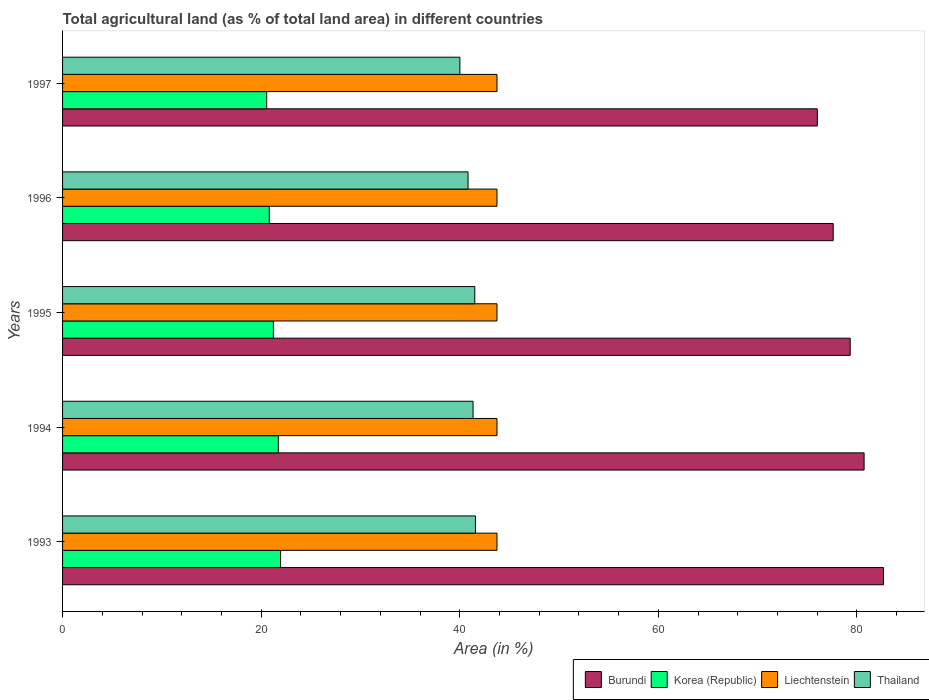What is the label of the 3rd group of bars from the top?
Make the answer very short. 1995. What is the percentage of agricultural land in Burundi in 1995?
Offer a terse response. 79.32. Across all years, what is the maximum percentage of agricultural land in Korea (Republic)?
Make the answer very short. 21.96. Across all years, what is the minimum percentage of agricultural land in Burundi?
Provide a succinct answer. 76.01. In which year was the percentage of agricultural land in Korea (Republic) maximum?
Provide a short and direct response. 1993. In which year was the percentage of agricultural land in Korea (Republic) minimum?
Your answer should be compact. 1997. What is the total percentage of agricultural land in Thailand in the graph?
Provide a succinct answer. 205.29. What is the difference between the percentage of agricultural land in Burundi in 1993 and that in 1997?
Give a very brief answer. 6.66. What is the difference between the percentage of agricultural land in Liechtenstein in 1994 and the percentage of agricultural land in Thailand in 1997?
Ensure brevity in your answer.  3.74. What is the average percentage of agricultural land in Burundi per year?
Ensure brevity in your answer.  79.27. In the year 1994, what is the difference between the percentage of agricultural land in Burundi and percentage of agricultural land in Thailand?
Your response must be concise. 39.38. What is the ratio of the percentage of agricultural land in Thailand in 1993 to that in 1994?
Keep it short and to the point. 1.01. Is the difference between the percentage of agricultural land in Burundi in 1993 and 1995 greater than the difference between the percentage of agricultural land in Thailand in 1993 and 1995?
Keep it short and to the point. Yes. What is the difference between the highest and the lowest percentage of agricultural land in Thailand?
Make the answer very short. 1.57. In how many years, is the percentage of agricultural land in Burundi greater than the average percentage of agricultural land in Burundi taken over all years?
Ensure brevity in your answer.  3. Is the sum of the percentage of agricultural land in Burundi in 1993 and 1996 greater than the maximum percentage of agricultural land in Korea (Republic) across all years?
Offer a very short reply. Yes. What does the 4th bar from the top in 1997 represents?
Your answer should be very brief. Burundi. What does the 1st bar from the bottom in 1997 represents?
Give a very brief answer. Burundi. Is it the case that in every year, the sum of the percentage of agricultural land in Korea (Republic) and percentage of agricultural land in Burundi is greater than the percentage of agricultural land in Thailand?
Offer a terse response. Yes. How many bars are there?
Your answer should be very brief. 20. Are all the bars in the graph horizontal?
Offer a very short reply. Yes. How many years are there in the graph?
Make the answer very short. 5. Are the values on the major ticks of X-axis written in scientific E-notation?
Provide a succinct answer. No. Does the graph contain grids?
Give a very brief answer. No. What is the title of the graph?
Your response must be concise. Total agricultural land (as % of total land area) in different countries. What is the label or title of the X-axis?
Your answer should be compact. Area (in %). What is the Area (in %) of Burundi in 1993?
Keep it short and to the point. 82.67. What is the Area (in %) of Korea (Republic) in 1993?
Make the answer very short. 21.96. What is the Area (in %) of Liechtenstein in 1993?
Offer a terse response. 43.75. What is the Area (in %) of Thailand in 1993?
Your answer should be compact. 41.58. What is the Area (in %) of Burundi in 1994?
Ensure brevity in your answer.  80.72. What is the Area (in %) in Korea (Republic) in 1994?
Your response must be concise. 21.73. What is the Area (in %) of Liechtenstein in 1994?
Give a very brief answer. 43.75. What is the Area (in %) in Thailand in 1994?
Your answer should be very brief. 41.34. What is the Area (in %) of Burundi in 1995?
Offer a terse response. 79.32. What is the Area (in %) of Korea (Republic) in 1995?
Your answer should be compact. 21.23. What is the Area (in %) in Liechtenstein in 1995?
Provide a short and direct response. 43.75. What is the Area (in %) of Thailand in 1995?
Provide a short and direct response. 41.52. What is the Area (in %) of Burundi in 1996?
Give a very brief answer. 77.61. What is the Area (in %) of Korea (Republic) in 1996?
Make the answer very short. 20.82. What is the Area (in %) of Liechtenstein in 1996?
Ensure brevity in your answer.  43.75. What is the Area (in %) in Thailand in 1996?
Offer a terse response. 40.84. What is the Area (in %) of Burundi in 1997?
Provide a succinct answer. 76.01. What is the Area (in %) in Korea (Republic) in 1997?
Make the answer very short. 20.56. What is the Area (in %) in Liechtenstein in 1997?
Ensure brevity in your answer.  43.75. What is the Area (in %) in Thailand in 1997?
Keep it short and to the point. 40.01. Across all years, what is the maximum Area (in %) in Burundi?
Your answer should be very brief. 82.67. Across all years, what is the maximum Area (in %) in Korea (Republic)?
Your answer should be very brief. 21.96. Across all years, what is the maximum Area (in %) of Liechtenstein?
Your answer should be very brief. 43.75. Across all years, what is the maximum Area (in %) in Thailand?
Provide a succinct answer. 41.58. Across all years, what is the minimum Area (in %) of Burundi?
Provide a short and direct response. 76.01. Across all years, what is the minimum Area (in %) of Korea (Republic)?
Your response must be concise. 20.56. Across all years, what is the minimum Area (in %) in Liechtenstein?
Provide a succinct answer. 43.75. Across all years, what is the minimum Area (in %) of Thailand?
Your answer should be compact. 40.01. What is the total Area (in %) of Burundi in the graph?
Provide a short and direct response. 396.34. What is the total Area (in %) of Korea (Republic) in the graph?
Your response must be concise. 106.29. What is the total Area (in %) of Liechtenstein in the graph?
Ensure brevity in your answer.  218.75. What is the total Area (in %) of Thailand in the graph?
Ensure brevity in your answer.  205.29. What is the difference between the Area (in %) of Burundi in 1993 and that in 1994?
Your response must be concise. 1.95. What is the difference between the Area (in %) in Korea (Republic) in 1993 and that in 1994?
Make the answer very short. 0.23. What is the difference between the Area (in %) in Liechtenstein in 1993 and that in 1994?
Provide a succinct answer. 0. What is the difference between the Area (in %) in Thailand in 1993 and that in 1994?
Ensure brevity in your answer.  0.24. What is the difference between the Area (in %) in Burundi in 1993 and that in 1995?
Offer a very short reply. 3.35. What is the difference between the Area (in %) in Korea (Republic) in 1993 and that in 1995?
Provide a succinct answer. 0.73. What is the difference between the Area (in %) of Thailand in 1993 and that in 1995?
Ensure brevity in your answer.  0.07. What is the difference between the Area (in %) in Burundi in 1993 and that in 1996?
Keep it short and to the point. 5.06. What is the difference between the Area (in %) in Korea (Republic) in 1993 and that in 1996?
Provide a succinct answer. 1.14. What is the difference between the Area (in %) of Liechtenstein in 1993 and that in 1996?
Your answer should be very brief. 0. What is the difference between the Area (in %) in Thailand in 1993 and that in 1996?
Keep it short and to the point. 0.75. What is the difference between the Area (in %) of Burundi in 1993 and that in 1997?
Provide a succinct answer. 6.66. What is the difference between the Area (in %) in Korea (Republic) in 1993 and that in 1997?
Your response must be concise. 1.4. What is the difference between the Area (in %) in Liechtenstein in 1993 and that in 1997?
Give a very brief answer. 0. What is the difference between the Area (in %) in Thailand in 1993 and that in 1997?
Provide a succinct answer. 1.57. What is the difference between the Area (in %) of Burundi in 1994 and that in 1995?
Give a very brief answer. 1.4. What is the difference between the Area (in %) of Korea (Republic) in 1994 and that in 1995?
Make the answer very short. 0.5. What is the difference between the Area (in %) of Liechtenstein in 1994 and that in 1995?
Ensure brevity in your answer.  0. What is the difference between the Area (in %) in Thailand in 1994 and that in 1995?
Offer a very short reply. -0.18. What is the difference between the Area (in %) in Burundi in 1994 and that in 1996?
Provide a short and direct response. 3.12. What is the difference between the Area (in %) of Korea (Republic) in 1994 and that in 1996?
Provide a short and direct response. 0.91. What is the difference between the Area (in %) in Thailand in 1994 and that in 1996?
Your answer should be compact. 0.5. What is the difference between the Area (in %) of Burundi in 1994 and that in 1997?
Provide a succinct answer. 4.71. What is the difference between the Area (in %) of Korea (Republic) in 1994 and that in 1997?
Offer a terse response. 1.17. What is the difference between the Area (in %) in Thailand in 1994 and that in 1997?
Offer a terse response. 1.33. What is the difference between the Area (in %) in Burundi in 1995 and that in 1996?
Your answer should be compact. 1.71. What is the difference between the Area (in %) in Korea (Republic) in 1995 and that in 1996?
Make the answer very short. 0.41. What is the difference between the Area (in %) in Liechtenstein in 1995 and that in 1996?
Offer a terse response. 0. What is the difference between the Area (in %) of Thailand in 1995 and that in 1996?
Provide a succinct answer. 0.68. What is the difference between the Area (in %) of Burundi in 1995 and that in 1997?
Make the answer very short. 3.31. What is the difference between the Area (in %) in Korea (Republic) in 1995 and that in 1997?
Offer a terse response. 0.67. What is the difference between the Area (in %) in Thailand in 1995 and that in 1997?
Keep it short and to the point. 1.5. What is the difference between the Area (in %) in Burundi in 1996 and that in 1997?
Provide a succinct answer. 1.6. What is the difference between the Area (in %) of Korea (Republic) in 1996 and that in 1997?
Your answer should be compact. 0.26. What is the difference between the Area (in %) of Liechtenstein in 1996 and that in 1997?
Provide a succinct answer. 0. What is the difference between the Area (in %) in Thailand in 1996 and that in 1997?
Offer a very short reply. 0.82. What is the difference between the Area (in %) in Burundi in 1993 and the Area (in %) in Korea (Republic) in 1994?
Offer a very short reply. 60.94. What is the difference between the Area (in %) of Burundi in 1993 and the Area (in %) of Liechtenstein in 1994?
Your answer should be compact. 38.92. What is the difference between the Area (in %) in Burundi in 1993 and the Area (in %) in Thailand in 1994?
Ensure brevity in your answer.  41.33. What is the difference between the Area (in %) in Korea (Republic) in 1993 and the Area (in %) in Liechtenstein in 1994?
Your answer should be compact. -21.79. What is the difference between the Area (in %) in Korea (Republic) in 1993 and the Area (in %) in Thailand in 1994?
Provide a short and direct response. -19.38. What is the difference between the Area (in %) in Liechtenstein in 1993 and the Area (in %) in Thailand in 1994?
Make the answer very short. 2.41. What is the difference between the Area (in %) of Burundi in 1993 and the Area (in %) of Korea (Republic) in 1995?
Your response must be concise. 61.44. What is the difference between the Area (in %) of Burundi in 1993 and the Area (in %) of Liechtenstein in 1995?
Your answer should be very brief. 38.92. What is the difference between the Area (in %) in Burundi in 1993 and the Area (in %) in Thailand in 1995?
Offer a terse response. 41.16. What is the difference between the Area (in %) in Korea (Republic) in 1993 and the Area (in %) in Liechtenstein in 1995?
Provide a short and direct response. -21.79. What is the difference between the Area (in %) in Korea (Republic) in 1993 and the Area (in %) in Thailand in 1995?
Offer a very short reply. -19.56. What is the difference between the Area (in %) in Liechtenstein in 1993 and the Area (in %) in Thailand in 1995?
Your answer should be very brief. 2.23. What is the difference between the Area (in %) in Burundi in 1993 and the Area (in %) in Korea (Republic) in 1996?
Give a very brief answer. 61.85. What is the difference between the Area (in %) of Burundi in 1993 and the Area (in %) of Liechtenstein in 1996?
Ensure brevity in your answer.  38.92. What is the difference between the Area (in %) in Burundi in 1993 and the Area (in %) in Thailand in 1996?
Provide a short and direct response. 41.83. What is the difference between the Area (in %) in Korea (Republic) in 1993 and the Area (in %) in Liechtenstein in 1996?
Give a very brief answer. -21.79. What is the difference between the Area (in %) in Korea (Republic) in 1993 and the Area (in %) in Thailand in 1996?
Your answer should be very brief. -18.88. What is the difference between the Area (in %) in Liechtenstein in 1993 and the Area (in %) in Thailand in 1996?
Your answer should be very brief. 2.91. What is the difference between the Area (in %) of Burundi in 1993 and the Area (in %) of Korea (Republic) in 1997?
Offer a very short reply. 62.11. What is the difference between the Area (in %) in Burundi in 1993 and the Area (in %) in Liechtenstein in 1997?
Your answer should be very brief. 38.92. What is the difference between the Area (in %) in Burundi in 1993 and the Area (in %) in Thailand in 1997?
Provide a succinct answer. 42.66. What is the difference between the Area (in %) of Korea (Republic) in 1993 and the Area (in %) of Liechtenstein in 1997?
Provide a short and direct response. -21.79. What is the difference between the Area (in %) in Korea (Republic) in 1993 and the Area (in %) in Thailand in 1997?
Provide a succinct answer. -18.06. What is the difference between the Area (in %) of Liechtenstein in 1993 and the Area (in %) of Thailand in 1997?
Your answer should be very brief. 3.74. What is the difference between the Area (in %) of Burundi in 1994 and the Area (in %) of Korea (Republic) in 1995?
Make the answer very short. 59.49. What is the difference between the Area (in %) of Burundi in 1994 and the Area (in %) of Liechtenstein in 1995?
Give a very brief answer. 36.97. What is the difference between the Area (in %) in Burundi in 1994 and the Area (in %) in Thailand in 1995?
Your response must be concise. 39.21. What is the difference between the Area (in %) in Korea (Republic) in 1994 and the Area (in %) in Liechtenstein in 1995?
Give a very brief answer. -22.02. What is the difference between the Area (in %) of Korea (Republic) in 1994 and the Area (in %) of Thailand in 1995?
Offer a very short reply. -19.79. What is the difference between the Area (in %) in Liechtenstein in 1994 and the Area (in %) in Thailand in 1995?
Ensure brevity in your answer.  2.23. What is the difference between the Area (in %) of Burundi in 1994 and the Area (in %) of Korea (Republic) in 1996?
Your response must be concise. 59.91. What is the difference between the Area (in %) of Burundi in 1994 and the Area (in %) of Liechtenstein in 1996?
Provide a short and direct response. 36.97. What is the difference between the Area (in %) of Burundi in 1994 and the Area (in %) of Thailand in 1996?
Give a very brief answer. 39.89. What is the difference between the Area (in %) in Korea (Republic) in 1994 and the Area (in %) in Liechtenstein in 1996?
Make the answer very short. -22.02. What is the difference between the Area (in %) of Korea (Republic) in 1994 and the Area (in %) of Thailand in 1996?
Your answer should be compact. -19.11. What is the difference between the Area (in %) of Liechtenstein in 1994 and the Area (in %) of Thailand in 1996?
Provide a succinct answer. 2.91. What is the difference between the Area (in %) of Burundi in 1994 and the Area (in %) of Korea (Republic) in 1997?
Offer a terse response. 60.17. What is the difference between the Area (in %) of Burundi in 1994 and the Area (in %) of Liechtenstein in 1997?
Make the answer very short. 36.97. What is the difference between the Area (in %) in Burundi in 1994 and the Area (in %) in Thailand in 1997?
Give a very brief answer. 40.71. What is the difference between the Area (in %) in Korea (Republic) in 1994 and the Area (in %) in Liechtenstein in 1997?
Ensure brevity in your answer.  -22.02. What is the difference between the Area (in %) of Korea (Republic) in 1994 and the Area (in %) of Thailand in 1997?
Offer a very short reply. -18.28. What is the difference between the Area (in %) of Liechtenstein in 1994 and the Area (in %) of Thailand in 1997?
Keep it short and to the point. 3.74. What is the difference between the Area (in %) of Burundi in 1995 and the Area (in %) of Korea (Republic) in 1996?
Your answer should be very brief. 58.51. What is the difference between the Area (in %) in Burundi in 1995 and the Area (in %) in Liechtenstein in 1996?
Make the answer very short. 35.57. What is the difference between the Area (in %) of Burundi in 1995 and the Area (in %) of Thailand in 1996?
Ensure brevity in your answer.  38.49. What is the difference between the Area (in %) of Korea (Republic) in 1995 and the Area (in %) of Liechtenstein in 1996?
Your response must be concise. -22.52. What is the difference between the Area (in %) in Korea (Republic) in 1995 and the Area (in %) in Thailand in 1996?
Keep it short and to the point. -19.61. What is the difference between the Area (in %) in Liechtenstein in 1995 and the Area (in %) in Thailand in 1996?
Your answer should be compact. 2.91. What is the difference between the Area (in %) of Burundi in 1995 and the Area (in %) of Korea (Republic) in 1997?
Provide a succinct answer. 58.76. What is the difference between the Area (in %) in Burundi in 1995 and the Area (in %) in Liechtenstein in 1997?
Your answer should be compact. 35.57. What is the difference between the Area (in %) of Burundi in 1995 and the Area (in %) of Thailand in 1997?
Your answer should be very brief. 39.31. What is the difference between the Area (in %) in Korea (Republic) in 1995 and the Area (in %) in Liechtenstein in 1997?
Your answer should be compact. -22.52. What is the difference between the Area (in %) of Korea (Republic) in 1995 and the Area (in %) of Thailand in 1997?
Make the answer very short. -18.78. What is the difference between the Area (in %) in Liechtenstein in 1995 and the Area (in %) in Thailand in 1997?
Your answer should be compact. 3.74. What is the difference between the Area (in %) in Burundi in 1996 and the Area (in %) in Korea (Republic) in 1997?
Your answer should be very brief. 57.05. What is the difference between the Area (in %) in Burundi in 1996 and the Area (in %) in Liechtenstein in 1997?
Give a very brief answer. 33.86. What is the difference between the Area (in %) in Burundi in 1996 and the Area (in %) in Thailand in 1997?
Your answer should be very brief. 37.6. What is the difference between the Area (in %) of Korea (Republic) in 1996 and the Area (in %) of Liechtenstein in 1997?
Give a very brief answer. -22.93. What is the difference between the Area (in %) of Korea (Republic) in 1996 and the Area (in %) of Thailand in 1997?
Your answer should be compact. -19.2. What is the difference between the Area (in %) in Liechtenstein in 1996 and the Area (in %) in Thailand in 1997?
Provide a succinct answer. 3.74. What is the average Area (in %) of Burundi per year?
Your response must be concise. 79.27. What is the average Area (in %) in Korea (Republic) per year?
Offer a very short reply. 21.26. What is the average Area (in %) in Liechtenstein per year?
Your answer should be compact. 43.75. What is the average Area (in %) of Thailand per year?
Your response must be concise. 41.06. In the year 1993, what is the difference between the Area (in %) in Burundi and Area (in %) in Korea (Republic)?
Make the answer very short. 60.71. In the year 1993, what is the difference between the Area (in %) of Burundi and Area (in %) of Liechtenstein?
Your response must be concise. 38.92. In the year 1993, what is the difference between the Area (in %) in Burundi and Area (in %) in Thailand?
Provide a succinct answer. 41.09. In the year 1993, what is the difference between the Area (in %) in Korea (Republic) and Area (in %) in Liechtenstein?
Keep it short and to the point. -21.79. In the year 1993, what is the difference between the Area (in %) in Korea (Republic) and Area (in %) in Thailand?
Offer a terse response. -19.63. In the year 1993, what is the difference between the Area (in %) of Liechtenstein and Area (in %) of Thailand?
Offer a very short reply. 2.17. In the year 1994, what is the difference between the Area (in %) of Burundi and Area (in %) of Korea (Republic)?
Offer a terse response. 59. In the year 1994, what is the difference between the Area (in %) in Burundi and Area (in %) in Liechtenstein?
Your response must be concise. 36.97. In the year 1994, what is the difference between the Area (in %) in Burundi and Area (in %) in Thailand?
Offer a very short reply. 39.38. In the year 1994, what is the difference between the Area (in %) of Korea (Republic) and Area (in %) of Liechtenstein?
Your answer should be compact. -22.02. In the year 1994, what is the difference between the Area (in %) in Korea (Republic) and Area (in %) in Thailand?
Offer a very short reply. -19.61. In the year 1994, what is the difference between the Area (in %) of Liechtenstein and Area (in %) of Thailand?
Provide a succinct answer. 2.41. In the year 1995, what is the difference between the Area (in %) in Burundi and Area (in %) in Korea (Republic)?
Provide a succinct answer. 58.09. In the year 1995, what is the difference between the Area (in %) in Burundi and Area (in %) in Liechtenstein?
Ensure brevity in your answer.  35.57. In the year 1995, what is the difference between the Area (in %) of Burundi and Area (in %) of Thailand?
Provide a short and direct response. 37.81. In the year 1995, what is the difference between the Area (in %) of Korea (Republic) and Area (in %) of Liechtenstein?
Keep it short and to the point. -22.52. In the year 1995, what is the difference between the Area (in %) in Korea (Republic) and Area (in %) in Thailand?
Your answer should be compact. -20.28. In the year 1995, what is the difference between the Area (in %) in Liechtenstein and Area (in %) in Thailand?
Offer a terse response. 2.23. In the year 1996, what is the difference between the Area (in %) of Burundi and Area (in %) of Korea (Republic)?
Provide a short and direct response. 56.79. In the year 1996, what is the difference between the Area (in %) in Burundi and Area (in %) in Liechtenstein?
Keep it short and to the point. 33.86. In the year 1996, what is the difference between the Area (in %) of Burundi and Area (in %) of Thailand?
Give a very brief answer. 36.77. In the year 1996, what is the difference between the Area (in %) of Korea (Republic) and Area (in %) of Liechtenstein?
Ensure brevity in your answer.  -22.93. In the year 1996, what is the difference between the Area (in %) of Korea (Republic) and Area (in %) of Thailand?
Provide a succinct answer. -20.02. In the year 1996, what is the difference between the Area (in %) of Liechtenstein and Area (in %) of Thailand?
Give a very brief answer. 2.91. In the year 1997, what is the difference between the Area (in %) of Burundi and Area (in %) of Korea (Republic)?
Provide a short and direct response. 55.45. In the year 1997, what is the difference between the Area (in %) in Burundi and Area (in %) in Liechtenstein?
Offer a terse response. 32.26. In the year 1997, what is the difference between the Area (in %) of Burundi and Area (in %) of Thailand?
Your answer should be compact. 36. In the year 1997, what is the difference between the Area (in %) of Korea (Republic) and Area (in %) of Liechtenstein?
Provide a succinct answer. -23.19. In the year 1997, what is the difference between the Area (in %) in Korea (Republic) and Area (in %) in Thailand?
Provide a succinct answer. -19.45. In the year 1997, what is the difference between the Area (in %) of Liechtenstein and Area (in %) of Thailand?
Offer a terse response. 3.74. What is the ratio of the Area (in %) of Burundi in 1993 to that in 1994?
Offer a terse response. 1.02. What is the ratio of the Area (in %) of Korea (Republic) in 1993 to that in 1994?
Offer a terse response. 1.01. What is the ratio of the Area (in %) in Liechtenstein in 1993 to that in 1994?
Your answer should be compact. 1. What is the ratio of the Area (in %) in Thailand in 1993 to that in 1994?
Keep it short and to the point. 1.01. What is the ratio of the Area (in %) in Burundi in 1993 to that in 1995?
Provide a short and direct response. 1.04. What is the ratio of the Area (in %) in Korea (Republic) in 1993 to that in 1995?
Give a very brief answer. 1.03. What is the ratio of the Area (in %) in Thailand in 1993 to that in 1995?
Make the answer very short. 1. What is the ratio of the Area (in %) of Burundi in 1993 to that in 1996?
Keep it short and to the point. 1.07. What is the ratio of the Area (in %) in Korea (Republic) in 1993 to that in 1996?
Provide a succinct answer. 1.05. What is the ratio of the Area (in %) of Liechtenstein in 1993 to that in 1996?
Offer a very short reply. 1. What is the ratio of the Area (in %) in Thailand in 1993 to that in 1996?
Make the answer very short. 1.02. What is the ratio of the Area (in %) of Burundi in 1993 to that in 1997?
Your answer should be very brief. 1.09. What is the ratio of the Area (in %) in Korea (Republic) in 1993 to that in 1997?
Offer a terse response. 1.07. What is the ratio of the Area (in %) of Thailand in 1993 to that in 1997?
Your answer should be very brief. 1.04. What is the ratio of the Area (in %) of Burundi in 1994 to that in 1995?
Offer a terse response. 1.02. What is the ratio of the Area (in %) in Korea (Republic) in 1994 to that in 1995?
Keep it short and to the point. 1.02. What is the ratio of the Area (in %) in Liechtenstein in 1994 to that in 1995?
Keep it short and to the point. 1. What is the ratio of the Area (in %) of Burundi in 1994 to that in 1996?
Ensure brevity in your answer.  1.04. What is the ratio of the Area (in %) of Korea (Republic) in 1994 to that in 1996?
Offer a very short reply. 1.04. What is the ratio of the Area (in %) of Liechtenstein in 1994 to that in 1996?
Your answer should be compact. 1. What is the ratio of the Area (in %) of Thailand in 1994 to that in 1996?
Provide a succinct answer. 1.01. What is the ratio of the Area (in %) in Burundi in 1994 to that in 1997?
Your answer should be very brief. 1.06. What is the ratio of the Area (in %) in Korea (Republic) in 1994 to that in 1997?
Your answer should be compact. 1.06. What is the ratio of the Area (in %) in Liechtenstein in 1994 to that in 1997?
Provide a short and direct response. 1. What is the ratio of the Area (in %) of Thailand in 1994 to that in 1997?
Ensure brevity in your answer.  1.03. What is the ratio of the Area (in %) of Burundi in 1995 to that in 1996?
Ensure brevity in your answer.  1.02. What is the ratio of the Area (in %) in Korea (Republic) in 1995 to that in 1996?
Provide a succinct answer. 1.02. What is the ratio of the Area (in %) of Liechtenstein in 1995 to that in 1996?
Your response must be concise. 1. What is the ratio of the Area (in %) in Thailand in 1995 to that in 1996?
Your response must be concise. 1.02. What is the ratio of the Area (in %) of Burundi in 1995 to that in 1997?
Offer a terse response. 1.04. What is the ratio of the Area (in %) of Korea (Republic) in 1995 to that in 1997?
Make the answer very short. 1.03. What is the ratio of the Area (in %) in Thailand in 1995 to that in 1997?
Your answer should be very brief. 1.04. What is the ratio of the Area (in %) in Korea (Republic) in 1996 to that in 1997?
Your answer should be very brief. 1.01. What is the ratio of the Area (in %) in Liechtenstein in 1996 to that in 1997?
Ensure brevity in your answer.  1. What is the ratio of the Area (in %) of Thailand in 1996 to that in 1997?
Offer a very short reply. 1.02. What is the difference between the highest and the second highest Area (in %) in Burundi?
Your answer should be compact. 1.95. What is the difference between the highest and the second highest Area (in %) in Korea (Republic)?
Give a very brief answer. 0.23. What is the difference between the highest and the second highest Area (in %) of Liechtenstein?
Make the answer very short. 0. What is the difference between the highest and the second highest Area (in %) in Thailand?
Your answer should be very brief. 0.07. What is the difference between the highest and the lowest Area (in %) in Burundi?
Your response must be concise. 6.66. What is the difference between the highest and the lowest Area (in %) of Korea (Republic)?
Offer a very short reply. 1.4. What is the difference between the highest and the lowest Area (in %) of Thailand?
Offer a terse response. 1.57. 